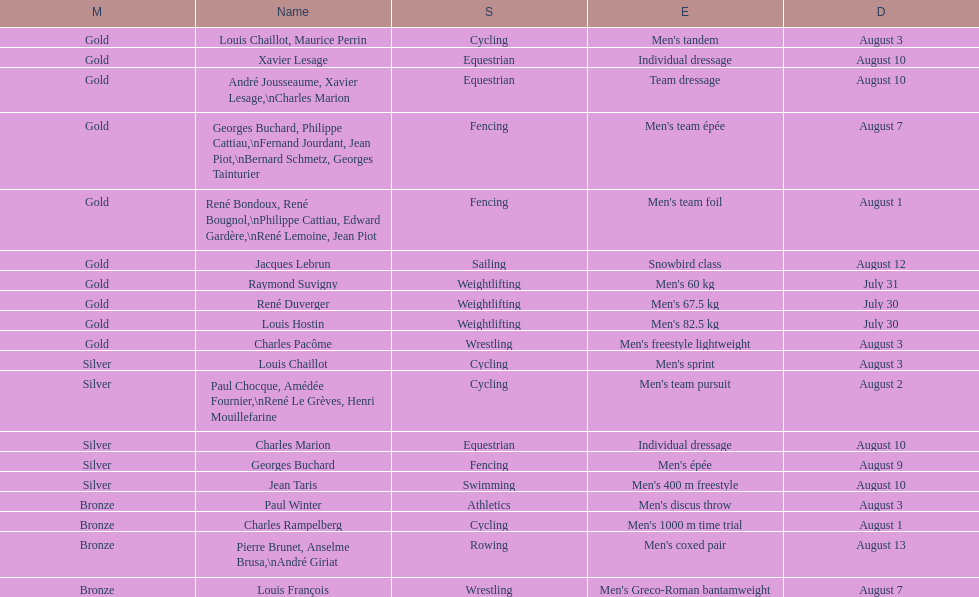What sport is listed first? Cycling. 